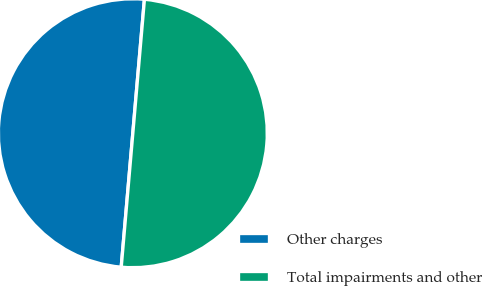Convert chart to OTSL. <chart><loc_0><loc_0><loc_500><loc_500><pie_chart><fcel>Other charges<fcel>Total impairments and other<nl><fcel>50.0%<fcel>50.0%<nl></chart> 